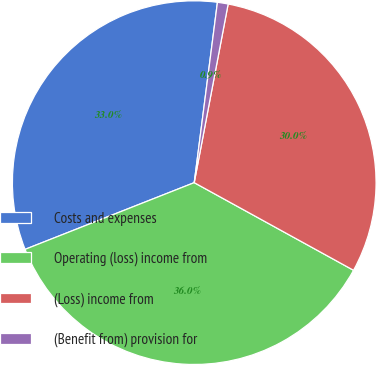Convert chart to OTSL. <chart><loc_0><loc_0><loc_500><loc_500><pie_chart><fcel>Costs and expenses<fcel>Operating (loss) income from<fcel>(Loss) income from<fcel>(Benefit from) provision for<nl><fcel>33.02%<fcel>36.02%<fcel>30.02%<fcel>0.95%<nl></chart> 